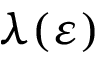Convert formula to latex. <formula><loc_0><loc_0><loc_500><loc_500>\lambda ( \varepsilon )</formula> 